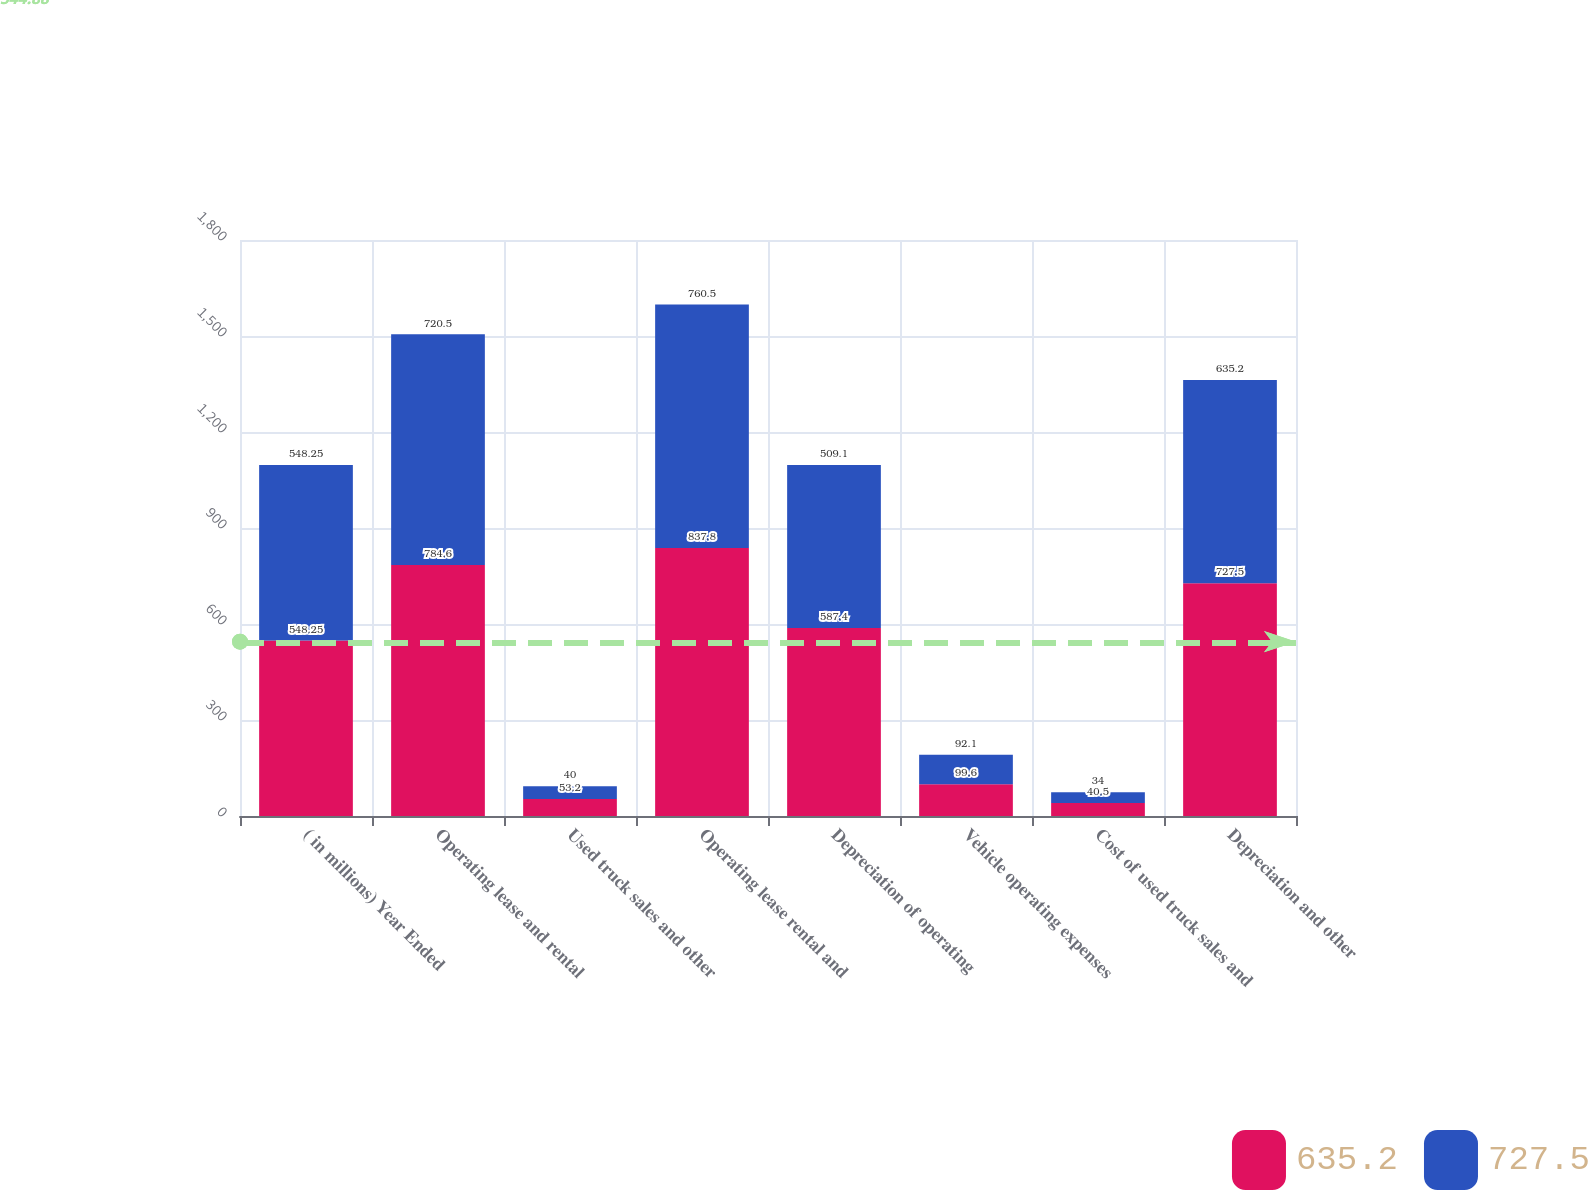Convert chart to OTSL. <chart><loc_0><loc_0><loc_500><loc_500><stacked_bar_chart><ecel><fcel>( in millions) Year Ended<fcel>Operating lease and rental<fcel>Used truck sales and other<fcel>Operating lease rental and<fcel>Depreciation of operating<fcel>Vehicle operating expenses<fcel>Cost of used truck sales and<fcel>Depreciation and other<nl><fcel>635.2<fcel>548.25<fcel>784.6<fcel>53.2<fcel>837.8<fcel>587.4<fcel>99.6<fcel>40.5<fcel>727.5<nl><fcel>727.5<fcel>548.25<fcel>720.5<fcel>40<fcel>760.5<fcel>509.1<fcel>92.1<fcel>34<fcel>635.2<nl></chart> 